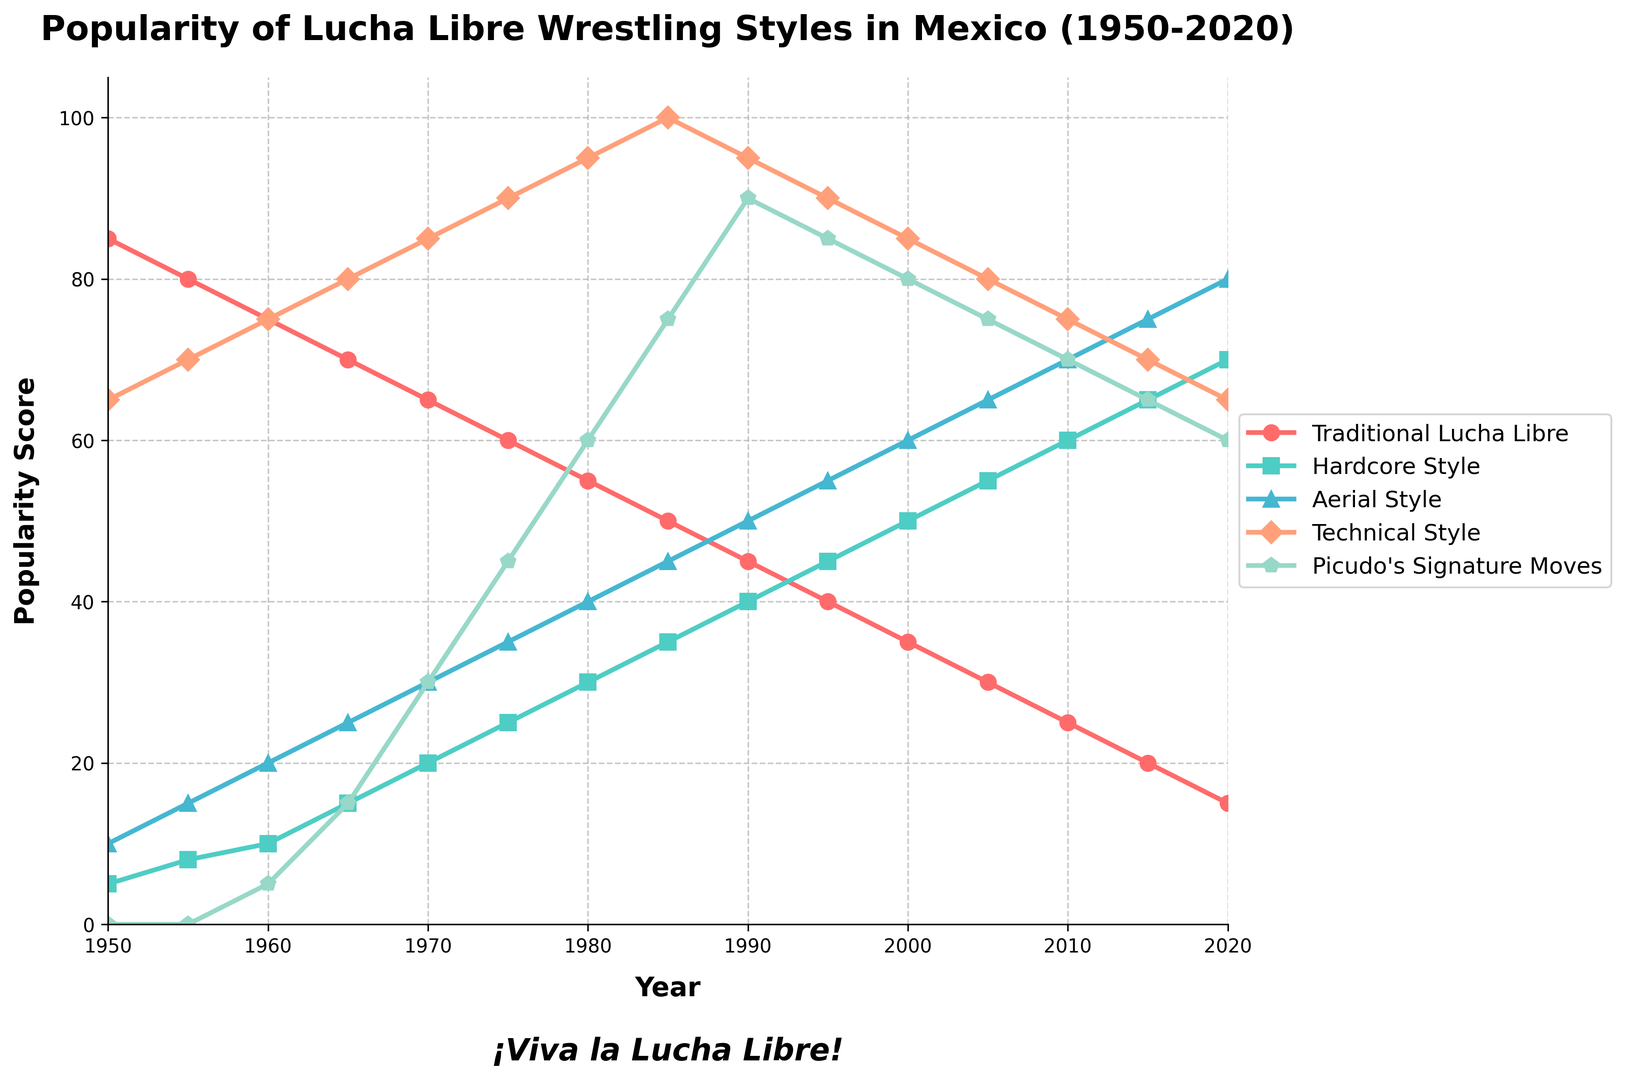What's the peak popularity score of Technical Style, and in which year did it occur? To find the peak popularity, look at the highest point on the Technical Style line. The Technical Style score is highest in 1985 at 100.
Answer: 100 in 1985 How does the popularity of Picudo's Signature Moves in 1990 compare to Traditional Lucha Libre in the same year? Compare the two values for 1990. Picudo's Signature Moves have a value of 90, while Traditional Lucha Libre has a value of 45.
Answer: Picudo’s Signature Moves are double that of Traditional Lucha Libre What is the total popularity score for Aerial Style between 1950 and 2020? Sum all the values for Aerial Style from the table. 10 + 15 + 20 + 25 + 30 + 35 + 40 + 45 + 50 + 55 + 60 + 65 + 70 + 75 + 80 = 655
Answer: 655 Which style had the steepest decline in popularity between 1950 and 2020? Examine the lines for each style from 1950 to 2020. Traditional Lucha Libre declines from 85 to 15, dropping 70 points, which is the steepest decline.
Answer: Traditional Lucha Libre Which styles were more popular than Hardcore Style in 1975? Compare the values for 1975. Hardcore Style has a value of 25. Traditional Lucha Libre (60) and Technical Style (90) have higher values.
Answer: Traditional Lucha Libre and Technical Style What is the average popularity score of Picudo's Signature Moves over the years it is available? Picudo's Signature Moves data is available from 1960 to 2020. Calculate the average: (5 + 15 + 30 + 45 + 60 + 75 + 90 + 85 + 80 + 75 + 70 + 65 + 60) / 13 = 58.08
Answer: 58.08 Which style saw an increase in popularity every decade from 1950 to 2020? Check the values for increments every ten years. Picudo's Signature Moves increase continuously until 1985, then starts to decline. None other increase every decade.
Answer: None In what year did Aerial Style first surpass Traditional Lucha Libre in popularity? Compare the values for each year. In 1990, Aerial Style (50) surpasses Traditional Lucha Libre (45).
Answer: 1990 By how much did the popularity of Hardcore Style increase from 1950 to 2020? Subtract the value of Hardcore Style in 1950 from the value in 2020: 70 - 5 = 65
Answer: 65 